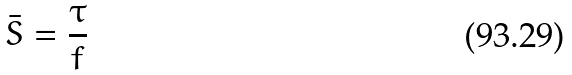<formula> <loc_0><loc_0><loc_500><loc_500>\bar { S } = \frac { \tau } { f }</formula> 